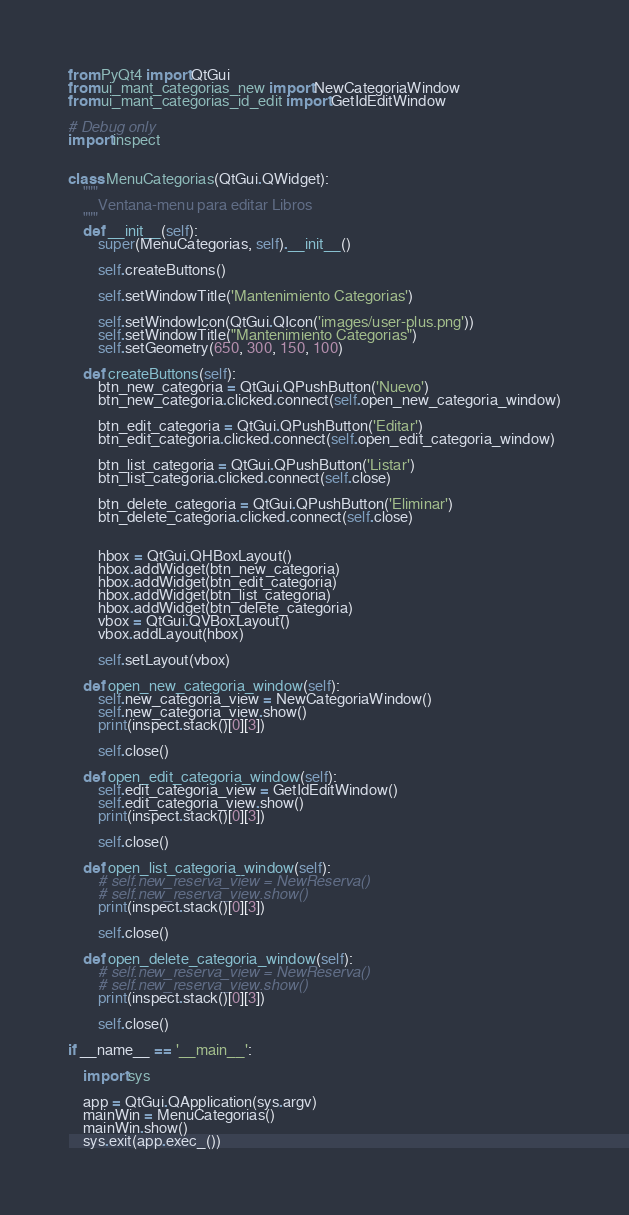<code> <loc_0><loc_0><loc_500><loc_500><_Python_>from PyQt4 import QtGui
from ui_mant_categorias_new import NewCategoriaWindow
from ui_mant_categorias_id_edit import GetIdEditWindow

# Debug only
import inspect


class MenuCategorias(QtGui.QWidget):
    """
        Ventana-menu para editar Libros
    """
    def __init__(self):
        super(MenuCategorias, self).__init__()

        self.createButtons()

        self.setWindowTitle('Mantenimiento Categorias')

        self.setWindowIcon(QtGui.QIcon('images/user-plus.png'))
        self.setWindowTitle("Mantenimiento Categorias")
        self.setGeometry(650, 300, 150, 100)

    def createButtons(self):
        btn_new_categoria = QtGui.QPushButton('Nuevo')
        btn_new_categoria.clicked.connect(self.open_new_categoria_window)

        btn_edit_categoria = QtGui.QPushButton('Editar')
        btn_edit_categoria.clicked.connect(self.open_edit_categoria_window)

        btn_list_categoria = QtGui.QPushButton('Listar')
        btn_list_categoria.clicked.connect(self.close)

        btn_delete_categoria = QtGui.QPushButton('Eliminar')
        btn_delete_categoria.clicked.connect(self.close)


        hbox = QtGui.QHBoxLayout()
        hbox.addWidget(btn_new_categoria)
        hbox.addWidget(btn_edit_categoria)
        hbox.addWidget(btn_list_categoria)
        hbox.addWidget(btn_delete_categoria)
        vbox = QtGui.QVBoxLayout()
        vbox.addLayout(hbox)

        self.setLayout(vbox)

    def open_new_categoria_window(self):
        self.new_categoria_view = NewCategoriaWindow()
        self.new_categoria_view.show()
        print(inspect.stack()[0][3])

        self.close()

    def open_edit_categoria_window(self):
        self.edit_categoria_view = GetIdEditWindow()
        self.edit_categoria_view.show()
        print(inspect.stack()[0][3])

        self.close()

    def open_list_categoria_window(self):
        # self.new_reserva_view = NewReserva()
        # self.new_reserva_view.show()
        print(inspect.stack()[0][3])

        self.close()

    def open_delete_categoria_window(self):
        # self.new_reserva_view = NewReserva()
        # self.new_reserva_view.show()
        print(inspect.stack()[0][3])

        self.close()

if __name__ == '__main__':

    import sys

    app = QtGui.QApplication(sys.argv)
    mainWin = MenuCategorias()
    mainWin.show()
    sys.exit(app.exec_())
</code> 